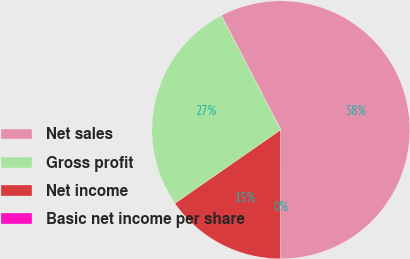Convert chart to OTSL. <chart><loc_0><loc_0><loc_500><loc_500><pie_chart><fcel>Net sales<fcel>Gross profit<fcel>Net income<fcel>Basic net income per share<nl><fcel>57.65%<fcel>27.04%<fcel>15.31%<fcel>0.0%<nl></chart> 